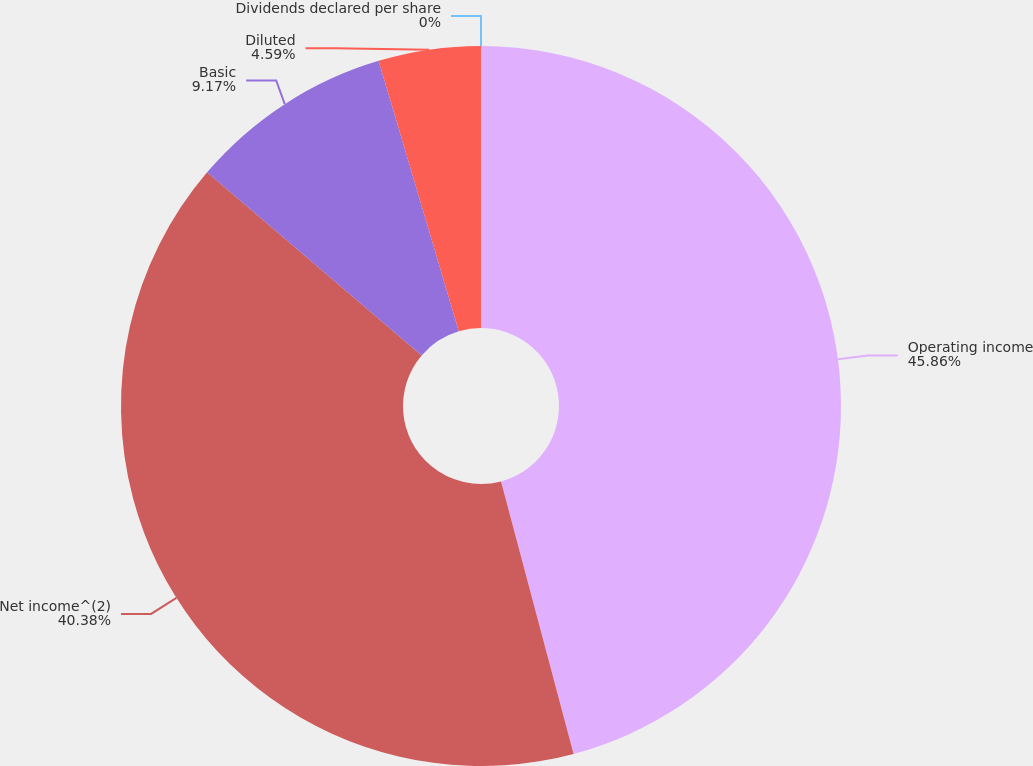<chart> <loc_0><loc_0><loc_500><loc_500><pie_chart><fcel>Operating income<fcel>Net income^(2)<fcel>Basic<fcel>Diluted<fcel>Dividends declared per share<nl><fcel>45.86%<fcel>40.38%<fcel>9.17%<fcel>4.59%<fcel>0.0%<nl></chart> 